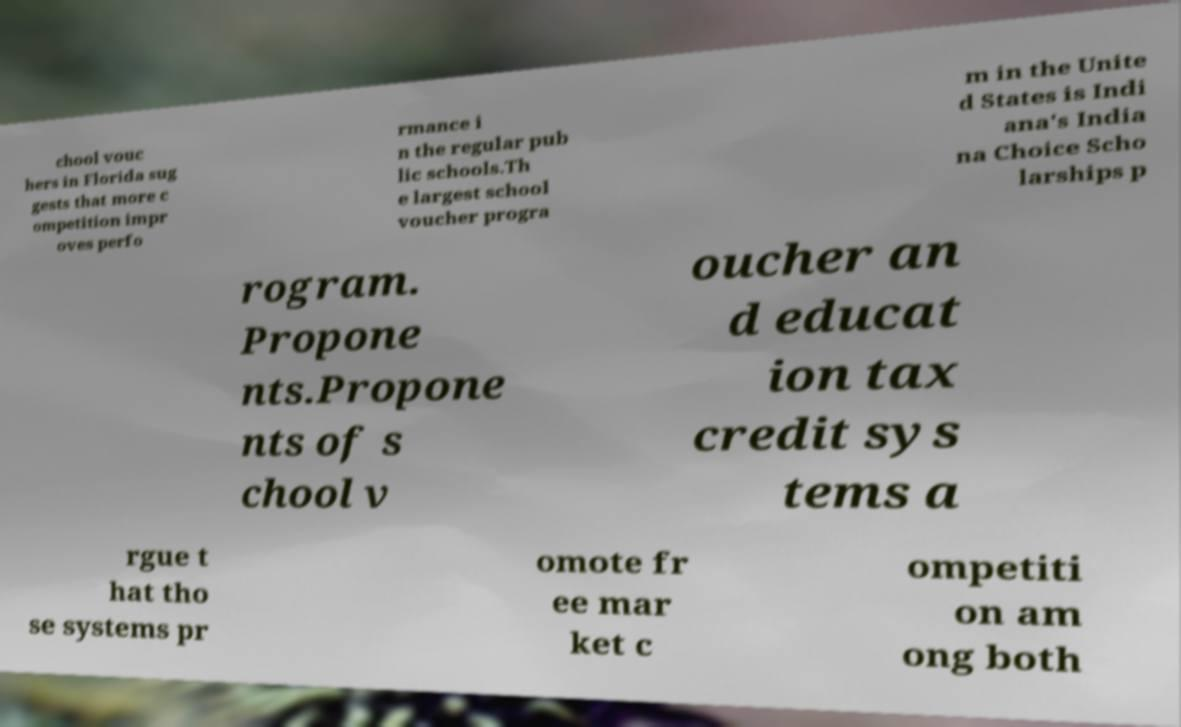Could you extract and type out the text from this image? chool vouc hers in Florida sug gests that more c ompetition impr oves perfo rmance i n the regular pub lic schools.Th e largest school voucher progra m in the Unite d States is Indi ana's India na Choice Scho larships p rogram. Propone nts.Propone nts of s chool v oucher an d educat ion tax credit sys tems a rgue t hat tho se systems pr omote fr ee mar ket c ompetiti on am ong both 